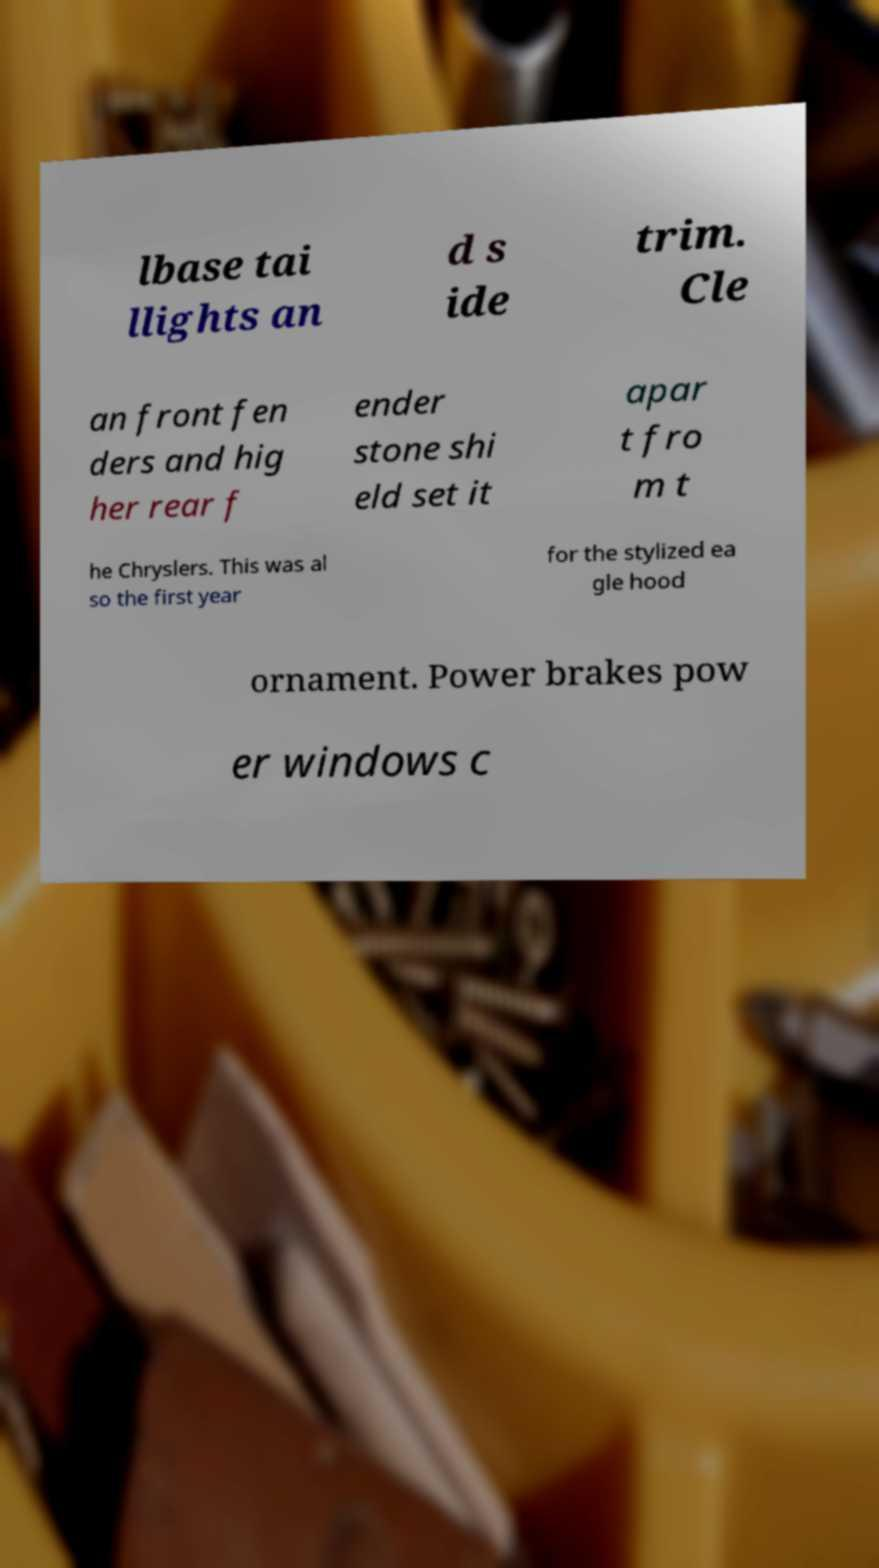For documentation purposes, I need the text within this image transcribed. Could you provide that? lbase tai llights an d s ide trim. Cle an front fen ders and hig her rear f ender stone shi eld set it apar t fro m t he Chryslers. This was al so the first year for the stylized ea gle hood ornament. Power brakes pow er windows c 